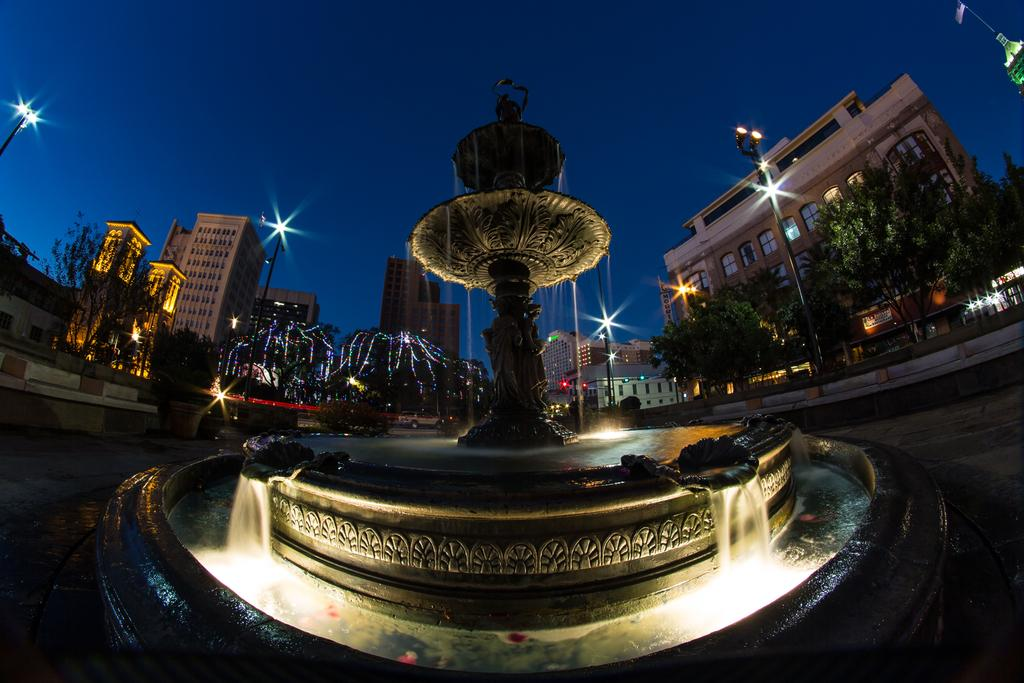What is the main feature in the middle of the image? There is a fountain in the middle of the image. What type of artwork can be seen in the image? There is a sculpture in the image. What type of structures are visible in the image? There are buildings in the image. What type of lighting is present in the image? Serial lights and light poles are visible in the image. What type of vegetation is present in the image? Plants and trees are in the image. What type of symbol is present in the image? There is a flag in the image. What part of the natural environment is visible in the image? The sky is visible in the image. Where is the seat located in the image? There is no seat present in the image. What type of force is being exerted on the fountain in the image? There is no force being exerted on the fountain in the image; it is stationary. 